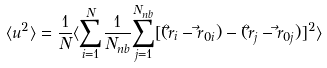Convert formula to latex. <formula><loc_0><loc_0><loc_500><loc_500>\langle u ^ { 2 } \rangle = \frac { 1 } { N } \langle \underset { i = 1 } { \overset { N } { \sum } } \frac { 1 } { N _ { n b } } \underset { j = 1 } { \overset { N _ { n b } } { \sum } } [ ( \vec { r } _ { i } - \vec { r } _ { 0 i } ) - ( \vec { r } _ { j } - \vec { r } _ { 0 j } ) ] ^ { 2 } \rangle</formula> 